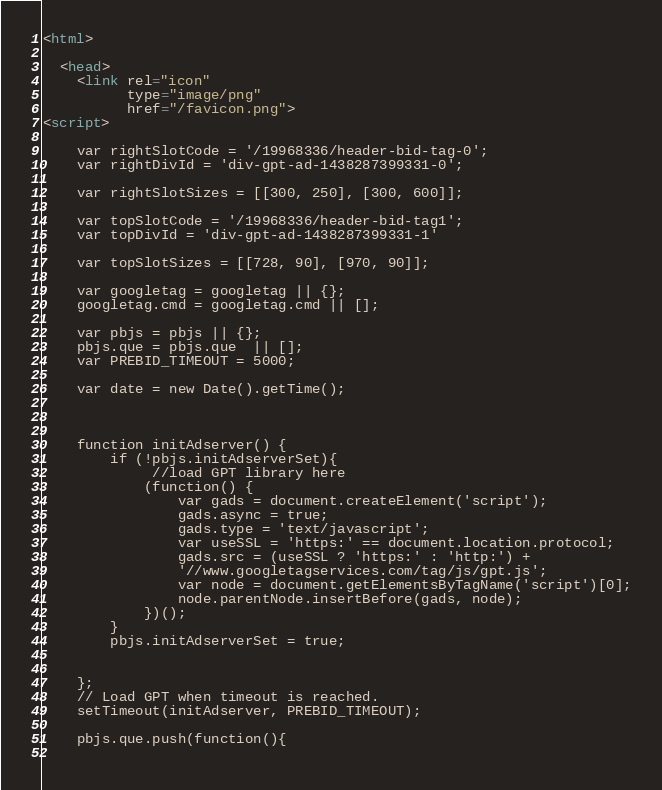Convert code to text. <code><loc_0><loc_0><loc_500><loc_500><_HTML_>
<html>

  <head>
    <link rel="icon" 
          type="image/png" 
          href="/favicon.png">
<script>

    var rightSlotCode = '/19968336/header-bid-tag-0';
    var rightDivId = 'div-gpt-ad-1438287399331-0';

    var rightSlotSizes = [[300, 250], [300, 600]];

    var topSlotCode = '/19968336/header-bid-tag1';
    var topDivId = 'div-gpt-ad-1438287399331-1'

    var topSlotSizes = [[728, 90], [970, 90]];

    var googletag = googletag || {};
    googletag.cmd = googletag.cmd || [];
    
    var pbjs = pbjs || {};
    pbjs.que = pbjs.que  || [];
    var PREBID_TIMEOUT = 5000;

    var date = new Date().getTime();



    function initAdserver() {
        if (!pbjs.initAdserverSet){
             //load GPT library here
            (function() {
                var gads = document.createElement('script');
                gads.async = true;
                gads.type = 'text/javascript';
                var useSSL = 'https:' == document.location.protocol;
                gads.src = (useSSL ? 'https:' : 'http:') +
                '//www.googletagservices.com/tag/js/gpt.js';
                var node = document.getElementsByTagName('script')[0];
                node.parentNode.insertBefore(gads, node);
            })();
        }
        pbjs.initAdserverSet = true;
        

    };
    // Load GPT when timeout is reached.
    setTimeout(initAdserver, PREBID_TIMEOUT);

    pbjs.que.push(function(){
       </code> 